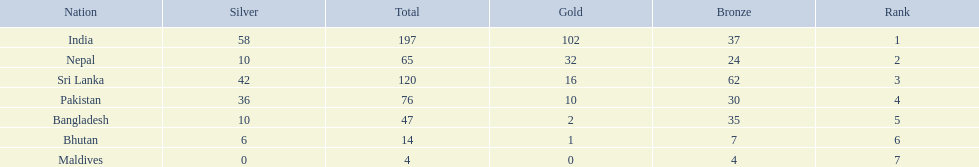What countries attended the 1999 south asian games? India, Nepal, Sri Lanka, Pakistan, Bangladesh, Bhutan, Maldives. Which of these countries had 32 gold medals? Nepal. 